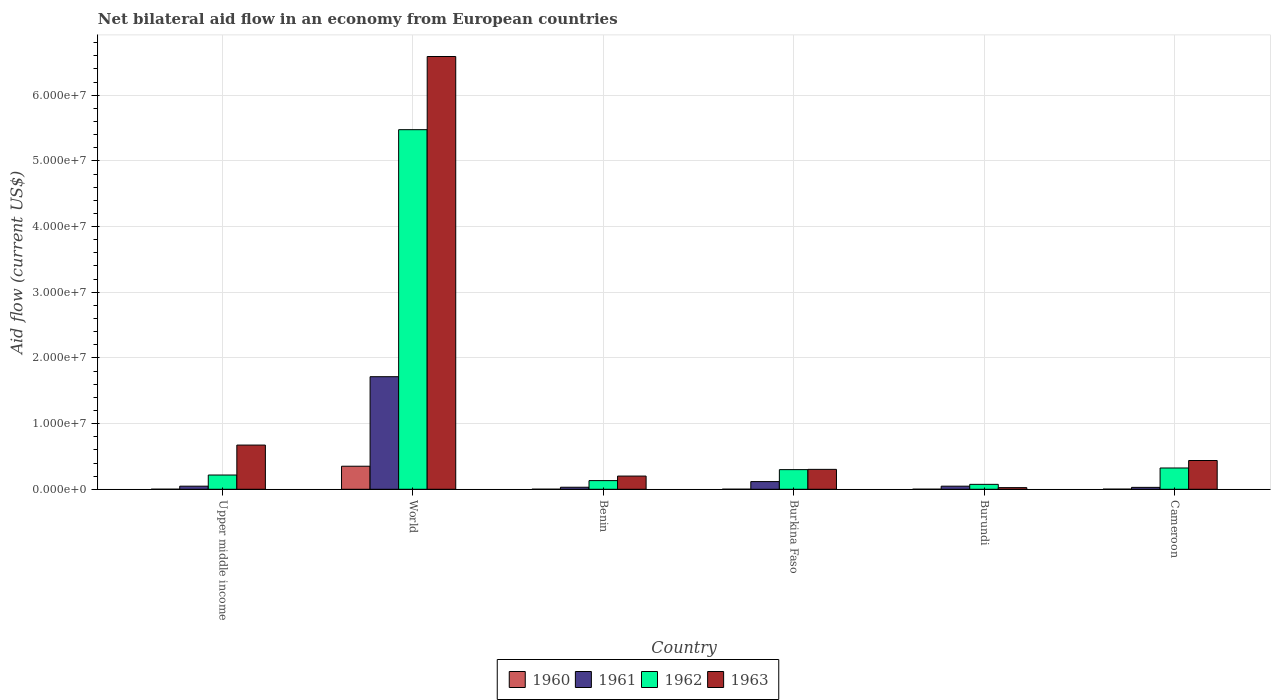How many groups of bars are there?
Provide a short and direct response. 6. What is the label of the 6th group of bars from the left?
Provide a succinct answer. Cameroon. What is the net bilateral aid flow in 1963 in World?
Ensure brevity in your answer.  6.59e+07. Across all countries, what is the maximum net bilateral aid flow in 1963?
Provide a short and direct response. 6.59e+07. In which country was the net bilateral aid flow in 1962 minimum?
Offer a very short reply. Burundi. What is the total net bilateral aid flow in 1961 in the graph?
Offer a very short reply. 1.98e+07. What is the difference between the net bilateral aid flow in 1962 in Benin and that in Cameroon?
Give a very brief answer. -1.92e+06. What is the difference between the net bilateral aid flow in 1962 in Burkina Faso and the net bilateral aid flow in 1960 in Benin?
Provide a short and direct response. 2.98e+06. What is the average net bilateral aid flow in 1960 per country?
Your answer should be very brief. 5.95e+05. What is the difference between the net bilateral aid flow of/in 1960 and net bilateral aid flow of/in 1961 in Burundi?
Ensure brevity in your answer.  -4.60e+05. What is the ratio of the net bilateral aid flow in 1961 in Benin to that in World?
Your response must be concise. 0.02. Is the net bilateral aid flow in 1961 in Benin less than that in Cameroon?
Keep it short and to the point. No. What is the difference between the highest and the second highest net bilateral aid flow in 1961?
Provide a short and direct response. 1.60e+07. What is the difference between the highest and the lowest net bilateral aid flow in 1960?
Provide a succinct answer. 3.50e+06. Is the sum of the net bilateral aid flow in 1960 in Upper middle income and World greater than the maximum net bilateral aid flow in 1962 across all countries?
Provide a succinct answer. No. Is it the case that in every country, the sum of the net bilateral aid flow in 1963 and net bilateral aid flow in 1962 is greater than the net bilateral aid flow in 1960?
Your response must be concise. Yes. Are all the bars in the graph horizontal?
Ensure brevity in your answer.  No. How many countries are there in the graph?
Provide a short and direct response. 6. Are the values on the major ticks of Y-axis written in scientific E-notation?
Your answer should be very brief. Yes. Does the graph contain any zero values?
Provide a short and direct response. No. How are the legend labels stacked?
Provide a succinct answer. Horizontal. What is the title of the graph?
Give a very brief answer. Net bilateral aid flow in an economy from European countries. What is the label or title of the X-axis?
Your response must be concise. Country. What is the label or title of the Y-axis?
Ensure brevity in your answer.  Aid flow (current US$). What is the Aid flow (current US$) in 1962 in Upper middle income?
Your answer should be compact. 2.17e+06. What is the Aid flow (current US$) in 1963 in Upper middle income?
Provide a short and direct response. 6.73e+06. What is the Aid flow (current US$) in 1960 in World?
Give a very brief answer. 3.51e+06. What is the Aid flow (current US$) of 1961 in World?
Offer a very short reply. 1.71e+07. What is the Aid flow (current US$) of 1962 in World?
Offer a terse response. 5.48e+07. What is the Aid flow (current US$) of 1963 in World?
Keep it short and to the point. 6.59e+07. What is the Aid flow (current US$) in 1962 in Benin?
Ensure brevity in your answer.  1.32e+06. What is the Aid flow (current US$) of 1963 in Benin?
Ensure brevity in your answer.  2.01e+06. What is the Aid flow (current US$) of 1961 in Burkina Faso?
Your answer should be very brief. 1.17e+06. What is the Aid flow (current US$) of 1962 in Burkina Faso?
Offer a terse response. 2.99e+06. What is the Aid flow (current US$) of 1963 in Burkina Faso?
Make the answer very short. 3.03e+06. What is the Aid flow (current US$) of 1960 in Burundi?
Provide a short and direct response. 10000. What is the Aid flow (current US$) of 1961 in Burundi?
Your response must be concise. 4.70e+05. What is the Aid flow (current US$) in 1962 in Burundi?
Ensure brevity in your answer.  7.50e+05. What is the Aid flow (current US$) in 1963 in Burundi?
Offer a very short reply. 2.50e+05. What is the Aid flow (current US$) in 1962 in Cameroon?
Your response must be concise. 3.24e+06. What is the Aid flow (current US$) of 1963 in Cameroon?
Provide a short and direct response. 4.38e+06. Across all countries, what is the maximum Aid flow (current US$) of 1960?
Provide a succinct answer. 3.51e+06. Across all countries, what is the maximum Aid flow (current US$) in 1961?
Ensure brevity in your answer.  1.71e+07. Across all countries, what is the maximum Aid flow (current US$) of 1962?
Offer a very short reply. 5.48e+07. Across all countries, what is the maximum Aid flow (current US$) in 1963?
Keep it short and to the point. 6.59e+07. Across all countries, what is the minimum Aid flow (current US$) in 1962?
Your answer should be very brief. 7.50e+05. What is the total Aid flow (current US$) in 1960 in the graph?
Offer a terse response. 3.57e+06. What is the total Aid flow (current US$) in 1961 in the graph?
Your answer should be very brief. 1.98e+07. What is the total Aid flow (current US$) in 1962 in the graph?
Offer a very short reply. 6.52e+07. What is the total Aid flow (current US$) of 1963 in the graph?
Your answer should be compact. 8.23e+07. What is the difference between the Aid flow (current US$) of 1960 in Upper middle income and that in World?
Provide a short and direct response. -3.50e+06. What is the difference between the Aid flow (current US$) of 1961 in Upper middle income and that in World?
Provide a succinct answer. -1.67e+07. What is the difference between the Aid flow (current US$) of 1962 in Upper middle income and that in World?
Offer a very short reply. -5.26e+07. What is the difference between the Aid flow (current US$) of 1963 in Upper middle income and that in World?
Offer a terse response. -5.92e+07. What is the difference between the Aid flow (current US$) in 1962 in Upper middle income and that in Benin?
Provide a succinct answer. 8.50e+05. What is the difference between the Aid flow (current US$) of 1963 in Upper middle income and that in Benin?
Offer a very short reply. 4.72e+06. What is the difference between the Aid flow (current US$) of 1961 in Upper middle income and that in Burkina Faso?
Ensure brevity in your answer.  -7.00e+05. What is the difference between the Aid flow (current US$) in 1962 in Upper middle income and that in Burkina Faso?
Ensure brevity in your answer.  -8.20e+05. What is the difference between the Aid flow (current US$) of 1963 in Upper middle income and that in Burkina Faso?
Provide a short and direct response. 3.70e+06. What is the difference between the Aid flow (current US$) of 1961 in Upper middle income and that in Burundi?
Your answer should be very brief. 0. What is the difference between the Aid flow (current US$) in 1962 in Upper middle income and that in Burundi?
Offer a terse response. 1.42e+06. What is the difference between the Aid flow (current US$) in 1963 in Upper middle income and that in Burundi?
Your answer should be compact. 6.48e+06. What is the difference between the Aid flow (current US$) in 1960 in Upper middle income and that in Cameroon?
Make the answer very short. -10000. What is the difference between the Aid flow (current US$) of 1961 in Upper middle income and that in Cameroon?
Your answer should be compact. 1.80e+05. What is the difference between the Aid flow (current US$) of 1962 in Upper middle income and that in Cameroon?
Your answer should be compact. -1.07e+06. What is the difference between the Aid flow (current US$) of 1963 in Upper middle income and that in Cameroon?
Offer a very short reply. 2.35e+06. What is the difference between the Aid flow (current US$) in 1960 in World and that in Benin?
Provide a succinct answer. 3.50e+06. What is the difference between the Aid flow (current US$) in 1961 in World and that in Benin?
Offer a terse response. 1.68e+07. What is the difference between the Aid flow (current US$) of 1962 in World and that in Benin?
Your answer should be very brief. 5.34e+07. What is the difference between the Aid flow (current US$) of 1963 in World and that in Benin?
Make the answer very short. 6.39e+07. What is the difference between the Aid flow (current US$) of 1960 in World and that in Burkina Faso?
Keep it short and to the point. 3.50e+06. What is the difference between the Aid flow (current US$) in 1961 in World and that in Burkina Faso?
Your answer should be compact. 1.60e+07. What is the difference between the Aid flow (current US$) of 1962 in World and that in Burkina Faso?
Keep it short and to the point. 5.18e+07. What is the difference between the Aid flow (current US$) in 1963 in World and that in Burkina Faso?
Make the answer very short. 6.29e+07. What is the difference between the Aid flow (current US$) in 1960 in World and that in Burundi?
Make the answer very short. 3.50e+06. What is the difference between the Aid flow (current US$) in 1961 in World and that in Burundi?
Provide a short and direct response. 1.67e+07. What is the difference between the Aid flow (current US$) of 1962 in World and that in Burundi?
Ensure brevity in your answer.  5.40e+07. What is the difference between the Aid flow (current US$) in 1963 in World and that in Burundi?
Offer a very short reply. 6.56e+07. What is the difference between the Aid flow (current US$) of 1960 in World and that in Cameroon?
Keep it short and to the point. 3.49e+06. What is the difference between the Aid flow (current US$) of 1961 in World and that in Cameroon?
Your answer should be very brief. 1.68e+07. What is the difference between the Aid flow (current US$) of 1962 in World and that in Cameroon?
Offer a very short reply. 5.15e+07. What is the difference between the Aid flow (current US$) in 1963 in World and that in Cameroon?
Your answer should be very brief. 6.15e+07. What is the difference between the Aid flow (current US$) of 1960 in Benin and that in Burkina Faso?
Your response must be concise. 0. What is the difference between the Aid flow (current US$) of 1961 in Benin and that in Burkina Faso?
Provide a succinct answer. -8.60e+05. What is the difference between the Aid flow (current US$) of 1962 in Benin and that in Burkina Faso?
Ensure brevity in your answer.  -1.67e+06. What is the difference between the Aid flow (current US$) in 1963 in Benin and that in Burkina Faso?
Your answer should be compact. -1.02e+06. What is the difference between the Aid flow (current US$) of 1961 in Benin and that in Burundi?
Provide a short and direct response. -1.60e+05. What is the difference between the Aid flow (current US$) of 1962 in Benin and that in Burundi?
Keep it short and to the point. 5.70e+05. What is the difference between the Aid flow (current US$) of 1963 in Benin and that in Burundi?
Provide a short and direct response. 1.76e+06. What is the difference between the Aid flow (current US$) of 1960 in Benin and that in Cameroon?
Provide a short and direct response. -10000. What is the difference between the Aid flow (current US$) of 1962 in Benin and that in Cameroon?
Provide a short and direct response. -1.92e+06. What is the difference between the Aid flow (current US$) in 1963 in Benin and that in Cameroon?
Make the answer very short. -2.37e+06. What is the difference between the Aid flow (current US$) in 1960 in Burkina Faso and that in Burundi?
Your response must be concise. 0. What is the difference between the Aid flow (current US$) of 1961 in Burkina Faso and that in Burundi?
Offer a terse response. 7.00e+05. What is the difference between the Aid flow (current US$) in 1962 in Burkina Faso and that in Burundi?
Provide a short and direct response. 2.24e+06. What is the difference between the Aid flow (current US$) of 1963 in Burkina Faso and that in Burundi?
Your answer should be very brief. 2.78e+06. What is the difference between the Aid flow (current US$) in 1960 in Burkina Faso and that in Cameroon?
Offer a terse response. -10000. What is the difference between the Aid flow (current US$) of 1961 in Burkina Faso and that in Cameroon?
Offer a very short reply. 8.80e+05. What is the difference between the Aid flow (current US$) of 1962 in Burkina Faso and that in Cameroon?
Your answer should be compact. -2.50e+05. What is the difference between the Aid flow (current US$) of 1963 in Burkina Faso and that in Cameroon?
Offer a terse response. -1.35e+06. What is the difference between the Aid flow (current US$) in 1960 in Burundi and that in Cameroon?
Your response must be concise. -10000. What is the difference between the Aid flow (current US$) in 1962 in Burundi and that in Cameroon?
Make the answer very short. -2.49e+06. What is the difference between the Aid flow (current US$) of 1963 in Burundi and that in Cameroon?
Your answer should be very brief. -4.13e+06. What is the difference between the Aid flow (current US$) in 1960 in Upper middle income and the Aid flow (current US$) in 1961 in World?
Offer a terse response. -1.71e+07. What is the difference between the Aid flow (current US$) in 1960 in Upper middle income and the Aid flow (current US$) in 1962 in World?
Make the answer very short. -5.47e+07. What is the difference between the Aid flow (current US$) of 1960 in Upper middle income and the Aid flow (current US$) of 1963 in World?
Your response must be concise. -6.59e+07. What is the difference between the Aid flow (current US$) in 1961 in Upper middle income and the Aid flow (current US$) in 1962 in World?
Your answer should be compact. -5.43e+07. What is the difference between the Aid flow (current US$) in 1961 in Upper middle income and the Aid flow (current US$) in 1963 in World?
Provide a succinct answer. -6.54e+07. What is the difference between the Aid flow (current US$) in 1962 in Upper middle income and the Aid flow (current US$) in 1963 in World?
Offer a terse response. -6.37e+07. What is the difference between the Aid flow (current US$) of 1960 in Upper middle income and the Aid flow (current US$) of 1961 in Benin?
Keep it short and to the point. -3.00e+05. What is the difference between the Aid flow (current US$) in 1960 in Upper middle income and the Aid flow (current US$) in 1962 in Benin?
Offer a very short reply. -1.31e+06. What is the difference between the Aid flow (current US$) of 1961 in Upper middle income and the Aid flow (current US$) of 1962 in Benin?
Your answer should be very brief. -8.50e+05. What is the difference between the Aid flow (current US$) of 1961 in Upper middle income and the Aid flow (current US$) of 1963 in Benin?
Give a very brief answer. -1.54e+06. What is the difference between the Aid flow (current US$) in 1960 in Upper middle income and the Aid flow (current US$) in 1961 in Burkina Faso?
Your response must be concise. -1.16e+06. What is the difference between the Aid flow (current US$) of 1960 in Upper middle income and the Aid flow (current US$) of 1962 in Burkina Faso?
Your answer should be very brief. -2.98e+06. What is the difference between the Aid flow (current US$) of 1960 in Upper middle income and the Aid flow (current US$) of 1963 in Burkina Faso?
Offer a terse response. -3.02e+06. What is the difference between the Aid flow (current US$) of 1961 in Upper middle income and the Aid flow (current US$) of 1962 in Burkina Faso?
Ensure brevity in your answer.  -2.52e+06. What is the difference between the Aid flow (current US$) of 1961 in Upper middle income and the Aid flow (current US$) of 1963 in Burkina Faso?
Keep it short and to the point. -2.56e+06. What is the difference between the Aid flow (current US$) of 1962 in Upper middle income and the Aid flow (current US$) of 1963 in Burkina Faso?
Keep it short and to the point. -8.60e+05. What is the difference between the Aid flow (current US$) of 1960 in Upper middle income and the Aid flow (current US$) of 1961 in Burundi?
Your answer should be very brief. -4.60e+05. What is the difference between the Aid flow (current US$) of 1960 in Upper middle income and the Aid flow (current US$) of 1962 in Burundi?
Your response must be concise. -7.40e+05. What is the difference between the Aid flow (current US$) in 1960 in Upper middle income and the Aid flow (current US$) in 1963 in Burundi?
Keep it short and to the point. -2.40e+05. What is the difference between the Aid flow (current US$) in 1961 in Upper middle income and the Aid flow (current US$) in 1962 in Burundi?
Offer a terse response. -2.80e+05. What is the difference between the Aid flow (current US$) of 1961 in Upper middle income and the Aid flow (current US$) of 1963 in Burundi?
Give a very brief answer. 2.20e+05. What is the difference between the Aid flow (current US$) of 1962 in Upper middle income and the Aid flow (current US$) of 1963 in Burundi?
Provide a short and direct response. 1.92e+06. What is the difference between the Aid flow (current US$) in 1960 in Upper middle income and the Aid flow (current US$) in 1961 in Cameroon?
Your response must be concise. -2.80e+05. What is the difference between the Aid flow (current US$) in 1960 in Upper middle income and the Aid flow (current US$) in 1962 in Cameroon?
Offer a terse response. -3.23e+06. What is the difference between the Aid flow (current US$) in 1960 in Upper middle income and the Aid flow (current US$) in 1963 in Cameroon?
Make the answer very short. -4.37e+06. What is the difference between the Aid flow (current US$) of 1961 in Upper middle income and the Aid flow (current US$) of 1962 in Cameroon?
Offer a terse response. -2.77e+06. What is the difference between the Aid flow (current US$) in 1961 in Upper middle income and the Aid flow (current US$) in 1963 in Cameroon?
Provide a short and direct response. -3.91e+06. What is the difference between the Aid flow (current US$) of 1962 in Upper middle income and the Aid flow (current US$) of 1963 in Cameroon?
Your answer should be compact. -2.21e+06. What is the difference between the Aid flow (current US$) of 1960 in World and the Aid flow (current US$) of 1961 in Benin?
Provide a succinct answer. 3.20e+06. What is the difference between the Aid flow (current US$) of 1960 in World and the Aid flow (current US$) of 1962 in Benin?
Give a very brief answer. 2.19e+06. What is the difference between the Aid flow (current US$) of 1960 in World and the Aid flow (current US$) of 1963 in Benin?
Ensure brevity in your answer.  1.50e+06. What is the difference between the Aid flow (current US$) of 1961 in World and the Aid flow (current US$) of 1962 in Benin?
Give a very brief answer. 1.58e+07. What is the difference between the Aid flow (current US$) in 1961 in World and the Aid flow (current US$) in 1963 in Benin?
Provide a short and direct response. 1.51e+07. What is the difference between the Aid flow (current US$) in 1962 in World and the Aid flow (current US$) in 1963 in Benin?
Make the answer very short. 5.27e+07. What is the difference between the Aid flow (current US$) in 1960 in World and the Aid flow (current US$) in 1961 in Burkina Faso?
Your response must be concise. 2.34e+06. What is the difference between the Aid flow (current US$) of 1960 in World and the Aid flow (current US$) of 1962 in Burkina Faso?
Give a very brief answer. 5.20e+05. What is the difference between the Aid flow (current US$) in 1960 in World and the Aid flow (current US$) in 1963 in Burkina Faso?
Your response must be concise. 4.80e+05. What is the difference between the Aid flow (current US$) of 1961 in World and the Aid flow (current US$) of 1962 in Burkina Faso?
Your answer should be compact. 1.42e+07. What is the difference between the Aid flow (current US$) in 1961 in World and the Aid flow (current US$) in 1963 in Burkina Faso?
Make the answer very short. 1.41e+07. What is the difference between the Aid flow (current US$) in 1962 in World and the Aid flow (current US$) in 1963 in Burkina Faso?
Your answer should be compact. 5.17e+07. What is the difference between the Aid flow (current US$) in 1960 in World and the Aid flow (current US$) in 1961 in Burundi?
Give a very brief answer. 3.04e+06. What is the difference between the Aid flow (current US$) of 1960 in World and the Aid flow (current US$) of 1962 in Burundi?
Your response must be concise. 2.76e+06. What is the difference between the Aid flow (current US$) of 1960 in World and the Aid flow (current US$) of 1963 in Burundi?
Your response must be concise. 3.26e+06. What is the difference between the Aid flow (current US$) of 1961 in World and the Aid flow (current US$) of 1962 in Burundi?
Provide a short and direct response. 1.64e+07. What is the difference between the Aid flow (current US$) of 1961 in World and the Aid flow (current US$) of 1963 in Burundi?
Your response must be concise. 1.69e+07. What is the difference between the Aid flow (current US$) in 1962 in World and the Aid flow (current US$) in 1963 in Burundi?
Give a very brief answer. 5.45e+07. What is the difference between the Aid flow (current US$) in 1960 in World and the Aid flow (current US$) in 1961 in Cameroon?
Ensure brevity in your answer.  3.22e+06. What is the difference between the Aid flow (current US$) of 1960 in World and the Aid flow (current US$) of 1962 in Cameroon?
Your answer should be compact. 2.70e+05. What is the difference between the Aid flow (current US$) of 1960 in World and the Aid flow (current US$) of 1963 in Cameroon?
Keep it short and to the point. -8.70e+05. What is the difference between the Aid flow (current US$) in 1961 in World and the Aid flow (current US$) in 1962 in Cameroon?
Offer a terse response. 1.39e+07. What is the difference between the Aid flow (current US$) in 1961 in World and the Aid flow (current US$) in 1963 in Cameroon?
Provide a succinct answer. 1.28e+07. What is the difference between the Aid flow (current US$) in 1962 in World and the Aid flow (current US$) in 1963 in Cameroon?
Ensure brevity in your answer.  5.04e+07. What is the difference between the Aid flow (current US$) of 1960 in Benin and the Aid flow (current US$) of 1961 in Burkina Faso?
Offer a very short reply. -1.16e+06. What is the difference between the Aid flow (current US$) of 1960 in Benin and the Aid flow (current US$) of 1962 in Burkina Faso?
Offer a very short reply. -2.98e+06. What is the difference between the Aid flow (current US$) in 1960 in Benin and the Aid flow (current US$) in 1963 in Burkina Faso?
Ensure brevity in your answer.  -3.02e+06. What is the difference between the Aid flow (current US$) of 1961 in Benin and the Aid flow (current US$) of 1962 in Burkina Faso?
Provide a short and direct response. -2.68e+06. What is the difference between the Aid flow (current US$) of 1961 in Benin and the Aid flow (current US$) of 1963 in Burkina Faso?
Offer a very short reply. -2.72e+06. What is the difference between the Aid flow (current US$) in 1962 in Benin and the Aid flow (current US$) in 1963 in Burkina Faso?
Your answer should be very brief. -1.71e+06. What is the difference between the Aid flow (current US$) in 1960 in Benin and the Aid flow (current US$) in 1961 in Burundi?
Ensure brevity in your answer.  -4.60e+05. What is the difference between the Aid flow (current US$) of 1960 in Benin and the Aid flow (current US$) of 1962 in Burundi?
Keep it short and to the point. -7.40e+05. What is the difference between the Aid flow (current US$) of 1961 in Benin and the Aid flow (current US$) of 1962 in Burundi?
Offer a terse response. -4.40e+05. What is the difference between the Aid flow (current US$) of 1962 in Benin and the Aid flow (current US$) of 1963 in Burundi?
Make the answer very short. 1.07e+06. What is the difference between the Aid flow (current US$) in 1960 in Benin and the Aid flow (current US$) in 1961 in Cameroon?
Offer a very short reply. -2.80e+05. What is the difference between the Aid flow (current US$) in 1960 in Benin and the Aid flow (current US$) in 1962 in Cameroon?
Provide a succinct answer. -3.23e+06. What is the difference between the Aid flow (current US$) in 1960 in Benin and the Aid flow (current US$) in 1963 in Cameroon?
Your answer should be compact. -4.37e+06. What is the difference between the Aid flow (current US$) in 1961 in Benin and the Aid flow (current US$) in 1962 in Cameroon?
Offer a very short reply. -2.93e+06. What is the difference between the Aid flow (current US$) of 1961 in Benin and the Aid flow (current US$) of 1963 in Cameroon?
Ensure brevity in your answer.  -4.07e+06. What is the difference between the Aid flow (current US$) of 1962 in Benin and the Aid flow (current US$) of 1963 in Cameroon?
Give a very brief answer. -3.06e+06. What is the difference between the Aid flow (current US$) in 1960 in Burkina Faso and the Aid flow (current US$) in 1961 in Burundi?
Provide a short and direct response. -4.60e+05. What is the difference between the Aid flow (current US$) in 1960 in Burkina Faso and the Aid flow (current US$) in 1962 in Burundi?
Your response must be concise. -7.40e+05. What is the difference between the Aid flow (current US$) in 1961 in Burkina Faso and the Aid flow (current US$) in 1963 in Burundi?
Make the answer very short. 9.20e+05. What is the difference between the Aid flow (current US$) of 1962 in Burkina Faso and the Aid flow (current US$) of 1963 in Burundi?
Your answer should be very brief. 2.74e+06. What is the difference between the Aid flow (current US$) in 1960 in Burkina Faso and the Aid flow (current US$) in 1961 in Cameroon?
Provide a short and direct response. -2.80e+05. What is the difference between the Aid flow (current US$) in 1960 in Burkina Faso and the Aid flow (current US$) in 1962 in Cameroon?
Give a very brief answer. -3.23e+06. What is the difference between the Aid flow (current US$) in 1960 in Burkina Faso and the Aid flow (current US$) in 1963 in Cameroon?
Provide a succinct answer. -4.37e+06. What is the difference between the Aid flow (current US$) of 1961 in Burkina Faso and the Aid flow (current US$) of 1962 in Cameroon?
Make the answer very short. -2.07e+06. What is the difference between the Aid flow (current US$) of 1961 in Burkina Faso and the Aid flow (current US$) of 1963 in Cameroon?
Keep it short and to the point. -3.21e+06. What is the difference between the Aid flow (current US$) in 1962 in Burkina Faso and the Aid flow (current US$) in 1963 in Cameroon?
Provide a succinct answer. -1.39e+06. What is the difference between the Aid flow (current US$) in 1960 in Burundi and the Aid flow (current US$) in 1961 in Cameroon?
Give a very brief answer. -2.80e+05. What is the difference between the Aid flow (current US$) in 1960 in Burundi and the Aid flow (current US$) in 1962 in Cameroon?
Offer a very short reply. -3.23e+06. What is the difference between the Aid flow (current US$) of 1960 in Burundi and the Aid flow (current US$) of 1963 in Cameroon?
Keep it short and to the point. -4.37e+06. What is the difference between the Aid flow (current US$) of 1961 in Burundi and the Aid flow (current US$) of 1962 in Cameroon?
Give a very brief answer. -2.77e+06. What is the difference between the Aid flow (current US$) of 1961 in Burundi and the Aid flow (current US$) of 1963 in Cameroon?
Your response must be concise. -3.91e+06. What is the difference between the Aid flow (current US$) of 1962 in Burundi and the Aid flow (current US$) of 1963 in Cameroon?
Make the answer very short. -3.63e+06. What is the average Aid flow (current US$) in 1960 per country?
Your answer should be very brief. 5.95e+05. What is the average Aid flow (current US$) in 1961 per country?
Offer a terse response. 3.31e+06. What is the average Aid flow (current US$) of 1962 per country?
Your response must be concise. 1.09e+07. What is the average Aid flow (current US$) of 1963 per country?
Keep it short and to the point. 1.37e+07. What is the difference between the Aid flow (current US$) in 1960 and Aid flow (current US$) in 1961 in Upper middle income?
Make the answer very short. -4.60e+05. What is the difference between the Aid flow (current US$) of 1960 and Aid flow (current US$) of 1962 in Upper middle income?
Your answer should be compact. -2.16e+06. What is the difference between the Aid flow (current US$) in 1960 and Aid flow (current US$) in 1963 in Upper middle income?
Offer a very short reply. -6.72e+06. What is the difference between the Aid flow (current US$) of 1961 and Aid flow (current US$) of 1962 in Upper middle income?
Your response must be concise. -1.70e+06. What is the difference between the Aid flow (current US$) in 1961 and Aid flow (current US$) in 1963 in Upper middle income?
Offer a terse response. -6.26e+06. What is the difference between the Aid flow (current US$) in 1962 and Aid flow (current US$) in 1963 in Upper middle income?
Your answer should be compact. -4.56e+06. What is the difference between the Aid flow (current US$) of 1960 and Aid flow (current US$) of 1961 in World?
Keep it short and to the point. -1.36e+07. What is the difference between the Aid flow (current US$) of 1960 and Aid flow (current US$) of 1962 in World?
Offer a very short reply. -5.12e+07. What is the difference between the Aid flow (current US$) of 1960 and Aid flow (current US$) of 1963 in World?
Keep it short and to the point. -6.24e+07. What is the difference between the Aid flow (current US$) of 1961 and Aid flow (current US$) of 1962 in World?
Keep it short and to the point. -3.76e+07. What is the difference between the Aid flow (current US$) in 1961 and Aid flow (current US$) in 1963 in World?
Keep it short and to the point. -4.88e+07. What is the difference between the Aid flow (current US$) in 1962 and Aid flow (current US$) in 1963 in World?
Your answer should be compact. -1.11e+07. What is the difference between the Aid flow (current US$) in 1960 and Aid flow (current US$) in 1961 in Benin?
Provide a succinct answer. -3.00e+05. What is the difference between the Aid flow (current US$) of 1960 and Aid flow (current US$) of 1962 in Benin?
Your response must be concise. -1.31e+06. What is the difference between the Aid flow (current US$) of 1960 and Aid flow (current US$) of 1963 in Benin?
Make the answer very short. -2.00e+06. What is the difference between the Aid flow (current US$) in 1961 and Aid flow (current US$) in 1962 in Benin?
Offer a very short reply. -1.01e+06. What is the difference between the Aid flow (current US$) of 1961 and Aid flow (current US$) of 1963 in Benin?
Your answer should be very brief. -1.70e+06. What is the difference between the Aid flow (current US$) of 1962 and Aid flow (current US$) of 1963 in Benin?
Offer a very short reply. -6.90e+05. What is the difference between the Aid flow (current US$) of 1960 and Aid flow (current US$) of 1961 in Burkina Faso?
Your answer should be very brief. -1.16e+06. What is the difference between the Aid flow (current US$) of 1960 and Aid flow (current US$) of 1962 in Burkina Faso?
Offer a very short reply. -2.98e+06. What is the difference between the Aid flow (current US$) of 1960 and Aid flow (current US$) of 1963 in Burkina Faso?
Your response must be concise. -3.02e+06. What is the difference between the Aid flow (current US$) of 1961 and Aid flow (current US$) of 1962 in Burkina Faso?
Ensure brevity in your answer.  -1.82e+06. What is the difference between the Aid flow (current US$) in 1961 and Aid flow (current US$) in 1963 in Burkina Faso?
Your response must be concise. -1.86e+06. What is the difference between the Aid flow (current US$) of 1960 and Aid flow (current US$) of 1961 in Burundi?
Ensure brevity in your answer.  -4.60e+05. What is the difference between the Aid flow (current US$) in 1960 and Aid flow (current US$) in 1962 in Burundi?
Give a very brief answer. -7.40e+05. What is the difference between the Aid flow (current US$) of 1961 and Aid flow (current US$) of 1962 in Burundi?
Your answer should be compact. -2.80e+05. What is the difference between the Aid flow (current US$) in 1960 and Aid flow (current US$) in 1961 in Cameroon?
Give a very brief answer. -2.70e+05. What is the difference between the Aid flow (current US$) in 1960 and Aid flow (current US$) in 1962 in Cameroon?
Provide a succinct answer. -3.22e+06. What is the difference between the Aid flow (current US$) in 1960 and Aid flow (current US$) in 1963 in Cameroon?
Offer a very short reply. -4.36e+06. What is the difference between the Aid flow (current US$) in 1961 and Aid flow (current US$) in 1962 in Cameroon?
Give a very brief answer. -2.95e+06. What is the difference between the Aid flow (current US$) of 1961 and Aid flow (current US$) of 1963 in Cameroon?
Provide a succinct answer. -4.09e+06. What is the difference between the Aid flow (current US$) in 1962 and Aid flow (current US$) in 1963 in Cameroon?
Your answer should be very brief. -1.14e+06. What is the ratio of the Aid flow (current US$) in 1960 in Upper middle income to that in World?
Your answer should be very brief. 0. What is the ratio of the Aid flow (current US$) of 1961 in Upper middle income to that in World?
Your answer should be very brief. 0.03. What is the ratio of the Aid flow (current US$) in 1962 in Upper middle income to that in World?
Provide a succinct answer. 0.04. What is the ratio of the Aid flow (current US$) in 1963 in Upper middle income to that in World?
Your response must be concise. 0.1. What is the ratio of the Aid flow (current US$) in 1961 in Upper middle income to that in Benin?
Make the answer very short. 1.52. What is the ratio of the Aid flow (current US$) of 1962 in Upper middle income to that in Benin?
Your response must be concise. 1.64. What is the ratio of the Aid flow (current US$) in 1963 in Upper middle income to that in Benin?
Your answer should be compact. 3.35. What is the ratio of the Aid flow (current US$) of 1961 in Upper middle income to that in Burkina Faso?
Your answer should be compact. 0.4. What is the ratio of the Aid flow (current US$) of 1962 in Upper middle income to that in Burkina Faso?
Offer a very short reply. 0.73. What is the ratio of the Aid flow (current US$) of 1963 in Upper middle income to that in Burkina Faso?
Give a very brief answer. 2.22. What is the ratio of the Aid flow (current US$) in 1960 in Upper middle income to that in Burundi?
Your answer should be very brief. 1. What is the ratio of the Aid flow (current US$) of 1962 in Upper middle income to that in Burundi?
Give a very brief answer. 2.89. What is the ratio of the Aid flow (current US$) of 1963 in Upper middle income to that in Burundi?
Your answer should be compact. 26.92. What is the ratio of the Aid flow (current US$) in 1960 in Upper middle income to that in Cameroon?
Give a very brief answer. 0.5. What is the ratio of the Aid flow (current US$) of 1961 in Upper middle income to that in Cameroon?
Offer a very short reply. 1.62. What is the ratio of the Aid flow (current US$) of 1962 in Upper middle income to that in Cameroon?
Provide a short and direct response. 0.67. What is the ratio of the Aid flow (current US$) in 1963 in Upper middle income to that in Cameroon?
Give a very brief answer. 1.54. What is the ratio of the Aid flow (current US$) in 1960 in World to that in Benin?
Provide a succinct answer. 351. What is the ratio of the Aid flow (current US$) of 1961 in World to that in Benin?
Give a very brief answer. 55.29. What is the ratio of the Aid flow (current US$) of 1962 in World to that in Benin?
Provide a short and direct response. 41.48. What is the ratio of the Aid flow (current US$) of 1963 in World to that in Benin?
Keep it short and to the point. 32.78. What is the ratio of the Aid flow (current US$) in 1960 in World to that in Burkina Faso?
Provide a short and direct response. 351. What is the ratio of the Aid flow (current US$) of 1961 in World to that in Burkina Faso?
Make the answer very short. 14.65. What is the ratio of the Aid flow (current US$) of 1962 in World to that in Burkina Faso?
Your response must be concise. 18.31. What is the ratio of the Aid flow (current US$) of 1963 in World to that in Burkina Faso?
Your answer should be very brief. 21.75. What is the ratio of the Aid flow (current US$) of 1960 in World to that in Burundi?
Your answer should be very brief. 351. What is the ratio of the Aid flow (current US$) of 1961 in World to that in Burundi?
Provide a succinct answer. 36.47. What is the ratio of the Aid flow (current US$) in 1962 in World to that in Burundi?
Your answer should be compact. 73. What is the ratio of the Aid flow (current US$) in 1963 in World to that in Burundi?
Ensure brevity in your answer.  263.56. What is the ratio of the Aid flow (current US$) of 1960 in World to that in Cameroon?
Provide a short and direct response. 175.5. What is the ratio of the Aid flow (current US$) of 1961 in World to that in Cameroon?
Your answer should be very brief. 59.1. What is the ratio of the Aid flow (current US$) of 1962 in World to that in Cameroon?
Offer a very short reply. 16.9. What is the ratio of the Aid flow (current US$) in 1963 in World to that in Cameroon?
Your response must be concise. 15.04. What is the ratio of the Aid flow (current US$) of 1960 in Benin to that in Burkina Faso?
Your response must be concise. 1. What is the ratio of the Aid flow (current US$) of 1961 in Benin to that in Burkina Faso?
Keep it short and to the point. 0.27. What is the ratio of the Aid flow (current US$) in 1962 in Benin to that in Burkina Faso?
Make the answer very short. 0.44. What is the ratio of the Aid flow (current US$) in 1963 in Benin to that in Burkina Faso?
Your answer should be compact. 0.66. What is the ratio of the Aid flow (current US$) of 1960 in Benin to that in Burundi?
Offer a very short reply. 1. What is the ratio of the Aid flow (current US$) of 1961 in Benin to that in Burundi?
Your answer should be very brief. 0.66. What is the ratio of the Aid flow (current US$) in 1962 in Benin to that in Burundi?
Your response must be concise. 1.76. What is the ratio of the Aid flow (current US$) of 1963 in Benin to that in Burundi?
Offer a terse response. 8.04. What is the ratio of the Aid flow (current US$) in 1960 in Benin to that in Cameroon?
Your answer should be compact. 0.5. What is the ratio of the Aid flow (current US$) in 1961 in Benin to that in Cameroon?
Your answer should be compact. 1.07. What is the ratio of the Aid flow (current US$) of 1962 in Benin to that in Cameroon?
Give a very brief answer. 0.41. What is the ratio of the Aid flow (current US$) of 1963 in Benin to that in Cameroon?
Your answer should be very brief. 0.46. What is the ratio of the Aid flow (current US$) of 1960 in Burkina Faso to that in Burundi?
Ensure brevity in your answer.  1. What is the ratio of the Aid flow (current US$) of 1961 in Burkina Faso to that in Burundi?
Your response must be concise. 2.49. What is the ratio of the Aid flow (current US$) of 1962 in Burkina Faso to that in Burundi?
Offer a very short reply. 3.99. What is the ratio of the Aid flow (current US$) of 1963 in Burkina Faso to that in Burundi?
Make the answer very short. 12.12. What is the ratio of the Aid flow (current US$) of 1961 in Burkina Faso to that in Cameroon?
Provide a short and direct response. 4.03. What is the ratio of the Aid flow (current US$) of 1962 in Burkina Faso to that in Cameroon?
Offer a very short reply. 0.92. What is the ratio of the Aid flow (current US$) of 1963 in Burkina Faso to that in Cameroon?
Offer a terse response. 0.69. What is the ratio of the Aid flow (current US$) in 1961 in Burundi to that in Cameroon?
Ensure brevity in your answer.  1.62. What is the ratio of the Aid flow (current US$) in 1962 in Burundi to that in Cameroon?
Provide a succinct answer. 0.23. What is the ratio of the Aid flow (current US$) in 1963 in Burundi to that in Cameroon?
Keep it short and to the point. 0.06. What is the difference between the highest and the second highest Aid flow (current US$) in 1960?
Your answer should be compact. 3.49e+06. What is the difference between the highest and the second highest Aid flow (current US$) in 1961?
Your response must be concise. 1.60e+07. What is the difference between the highest and the second highest Aid flow (current US$) in 1962?
Give a very brief answer. 5.15e+07. What is the difference between the highest and the second highest Aid flow (current US$) of 1963?
Your response must be concise. 5.92e+07. What is the difference between the highest and the lowest Aid flow (current US$) of 1960?
Offer a terse response. 3.50e+06. What is the difference between the highest and the lowest Aid flow (current US$) in 1961?
Offer a terse response. 1.68e+07. What is the difference between the highest and the lowest Aid flow (current US$) in 1962?
Your answer should be very brief. 5.40e+07. What is the difference between the highest and the lowest Aid flow (current US$) in 1963?
Your answer should be compact. 6.56e+07. 